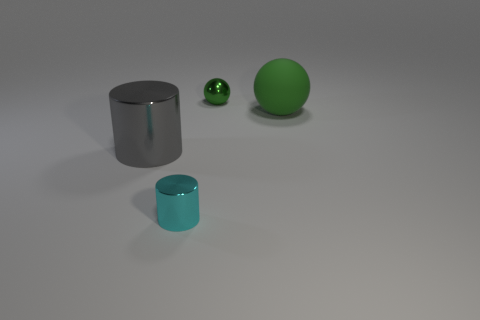Is there any other thing that has the same material as the large green thing?
Offer a very short reply. No. Does the sphere that is left of the large green rubber object have the same size as the shiny cylinder behind the small metal cylinder?
Offer a very short reply. No. There is a metallic object on the right side of the tiny metal cylinder; is it the same color as the big object that is behind the large metallic object?
Your response must be concise. Yes. There is a tiny shiny thing behind the tiny shiny object that is in front of the big green thing; what shape is it?
Provide a short and direct response. Sphere. Are the ball that is left of the matte thing and the large thing right of the tiny cyan metal object made of the same material?
Offer a terse response. No. There is a large object that is right of the gray metal cylinder; does it have the same shape as the metal object that is behind the gray metallic object?
Make the answer very short. Yes. How big is the object that is in front of the small shiny ball and behind the gray thing?
Offer a very short reply. Large. What color is the small object that is the same shape as the big green object?
Your response must be concise. Green. What color is the shiny object that is behind the metallic cylinder that is left of the cyan cylinder?
Provide a succinct answer. Green. The cyan shiny thing has what shape?
Your response must be concise. Cylinder. 